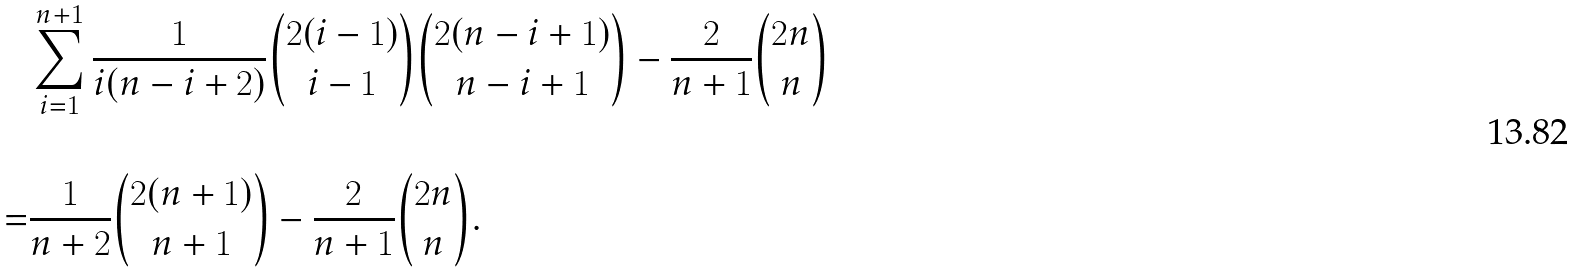Convert formula to latex. <formula><loc_0><loc_0><loc_500><loc_500>& \sum _ { i = 1 } ^ { n + 1 } \frac { 1 } { i ( n - i + 2 ) } { 2 ( i - 1 ) \choose i - 1 } { 2 ( n - i + 1 ) \choose n - i + 1 } - \frac { 2 } { n + 1 } { 2 n \choose n } \\ \\ = & \frac { 1 } { n + 2 } { 2 ( n + 1 ) \choose n + 1 } - \frac { 2 } { n + 1 } { 2 n \choose n } . \\</formula> 